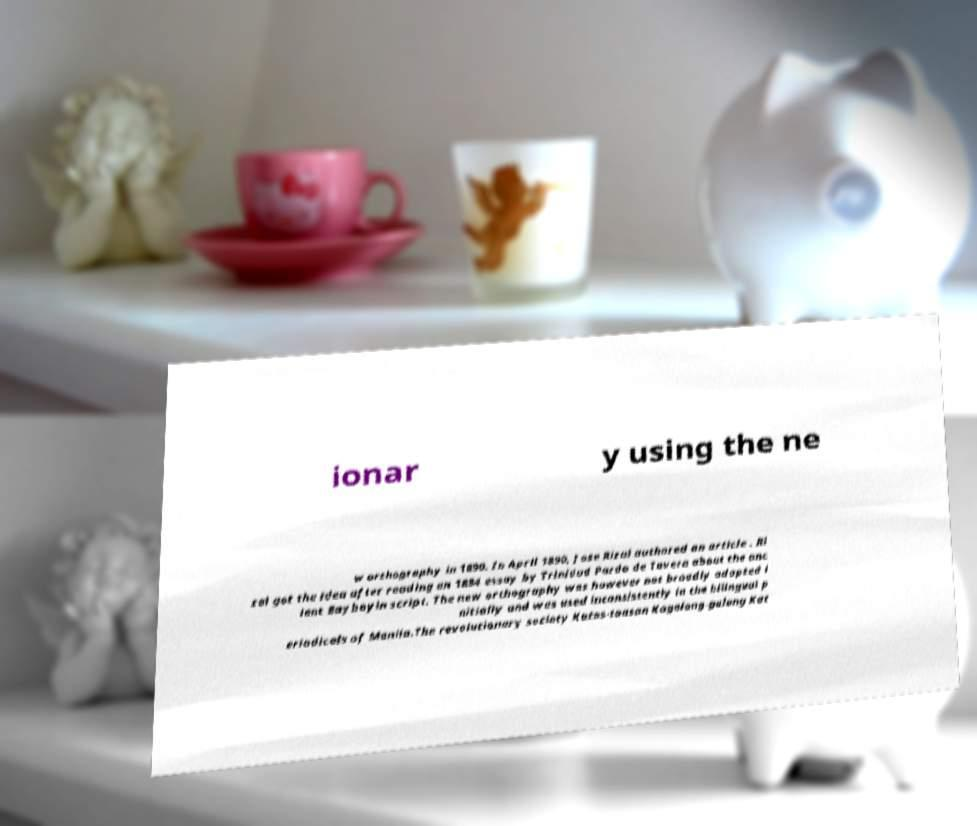For documentation purposes, I need the text within this image transcribed. Could you provide that? ionar y using the ne w orthography in 1890. In April 1890, Jose Rizal authored an article . Ri zal got the idea after reading an 1884 essay by Trinidad Pardo de Tavera about the anc ient Baybayin script. The new orthography was however not broadly adopted i nitially and was used inconsistently in the bilingual p eriodicals of Manila.The revolutionary society Katas-taasan Kagalang-galang Kat 